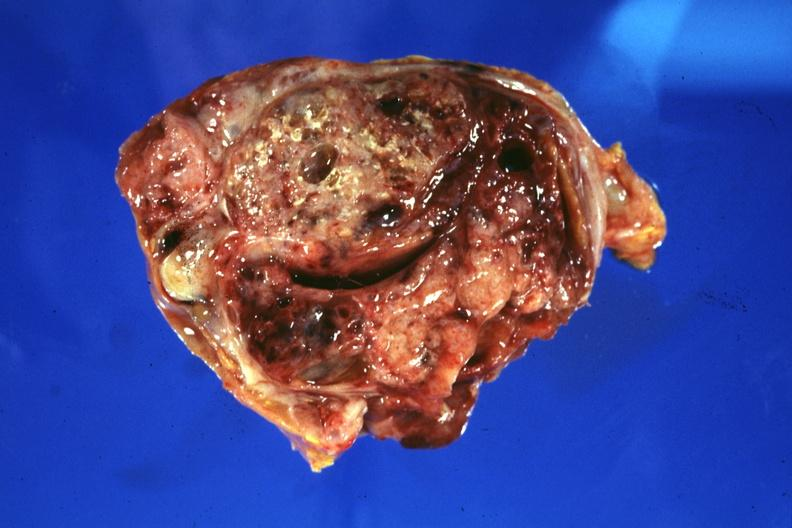does abdomen show cross section of tumor?
Answer the question using a single word or phrase. No 